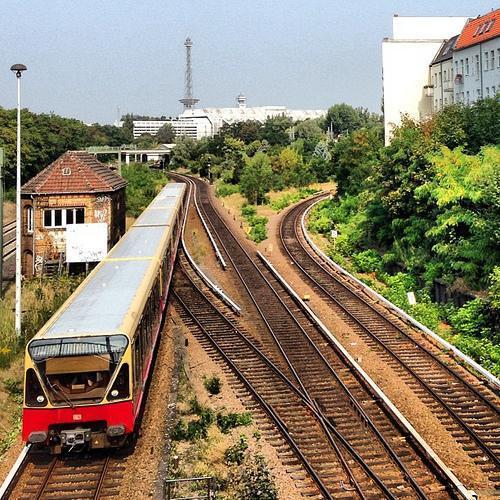How many trains are there?
Give a very brief answer. 1. 